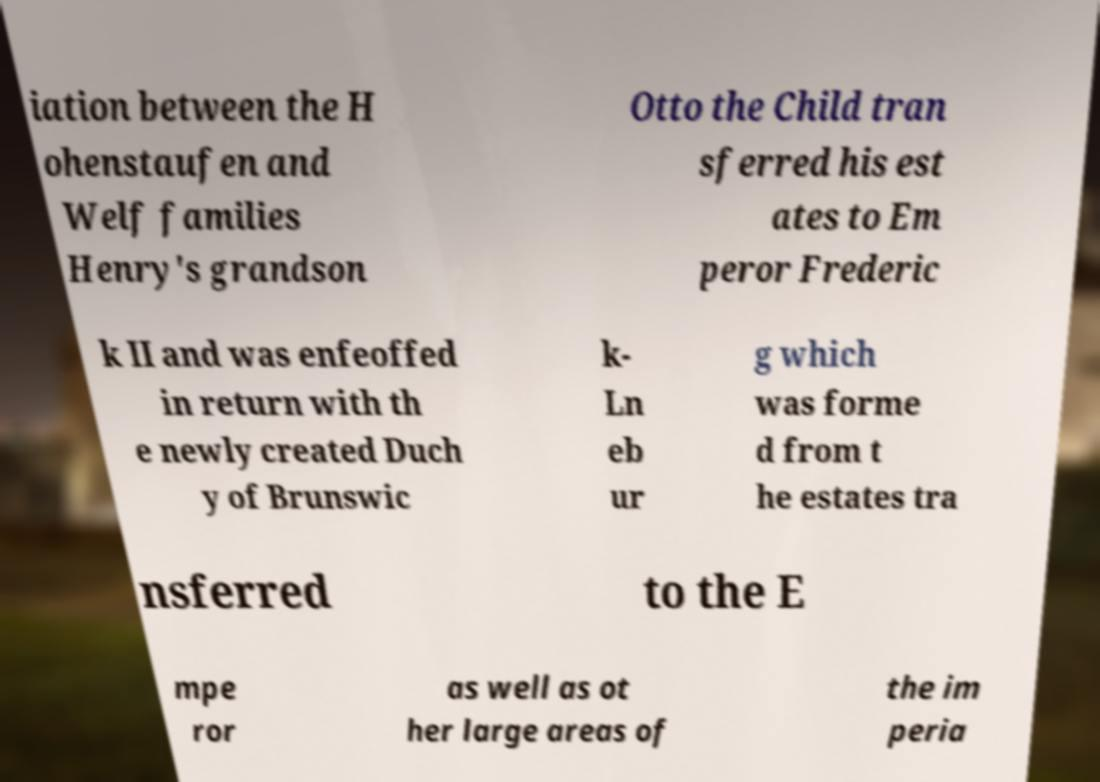Can you accurately transcribe the text from the provided image for me? iation between the H ohenstaufen and Welf families Henry's grandson Otto the Child tran sferred his est ates to Em peror Frederic k II and was enfeoffed in return with th e newly created Duch y of Brunswic k- Ln eb ur g which was forme d from t he estates tra nsferred to the E mpe ror as well as ot her large areas of the im peria 